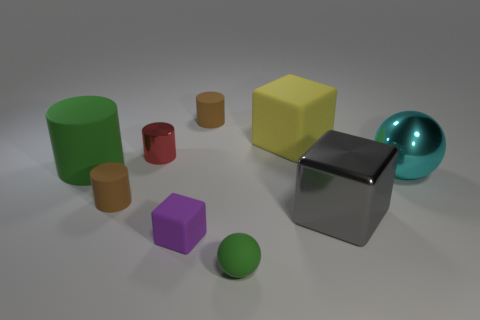There is a green object to the left of the purple rubber object; what is its material?
Your response must be concise. Rubber. What is the size of the matte object that is the same color as the large matte cylinder?
Provide a succinct answer. Small. How many things are tiny matte things that are in front of the big rubber cube or small blue matte spheres?
Ensure brevity in your answer.  3. Is the number of green matte spheres that are in front of the tiny green matte object the same as the number of large brown rubber spheres?
Make the answer very short. Yes. Is the yellow matte object the same size as the purple matte thing?
Keep it short and to the point. No. There is a cube that is the same size as the shiny cylinder; what is its color?
Keep it short and to the point. Purple. There is a gray thing; does it have the same size as the rubber block on the left side of the yellow rubber block?
Offer a very short reply. No. What number of tiny balls are the same color as the large cylinder?
Provide a succinct answer. 1. What number of objects are either brown rubber cylinders or matte objects that are to the left of the matte ball?
Offer a terse response. 4. There is a sphere that is on the left side of the yellow rubber cube; does it have the same size as the ball that is to the right of the tiny green rubber ball?
Offer a terse response. No. 